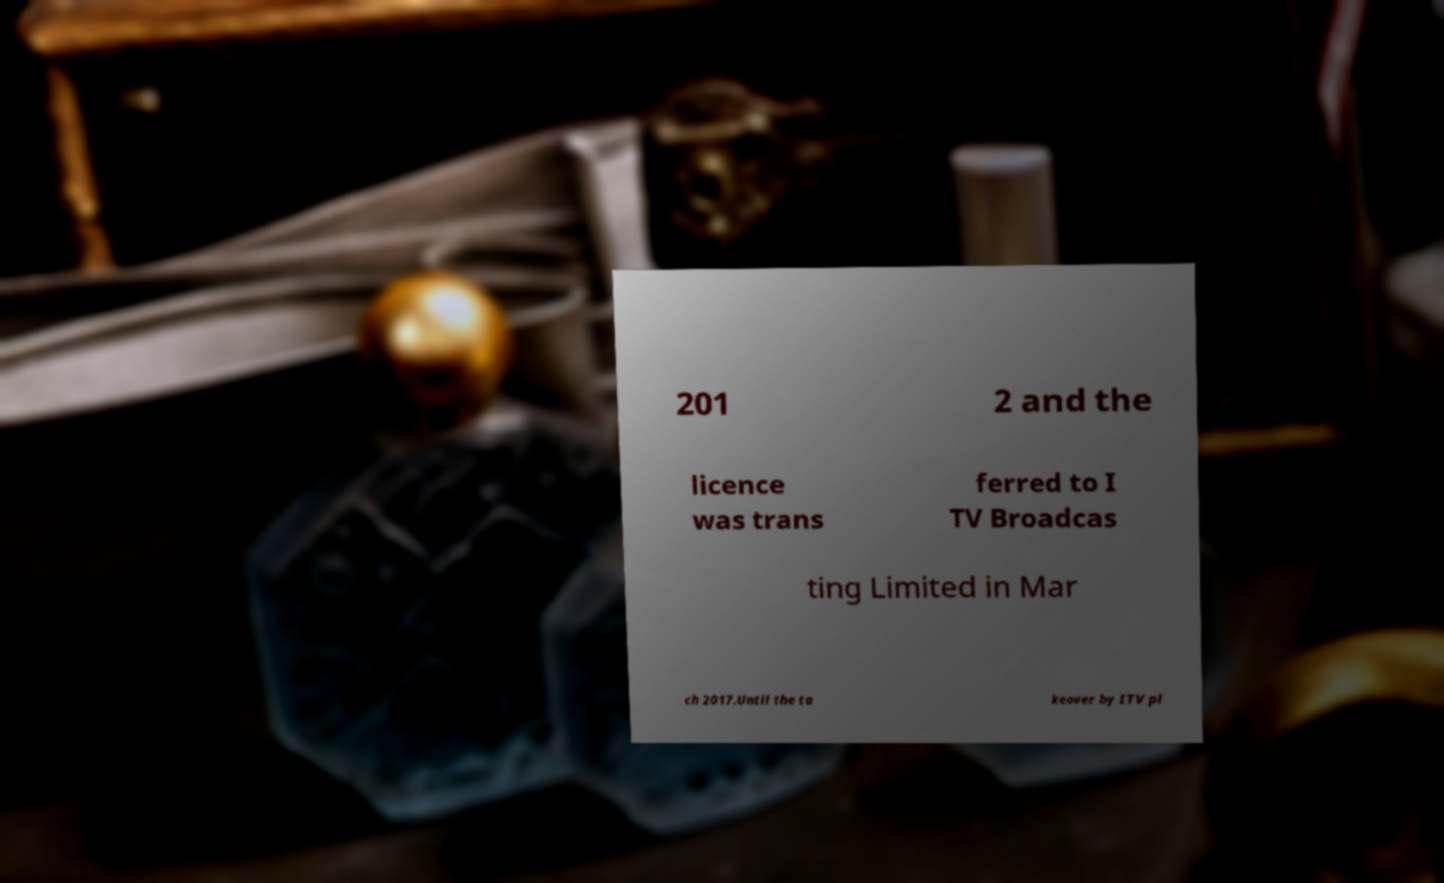There's text embedded in this image that I need extracted. Can you transcribe it verbatim? 201 2 and the licence was trans ferred to I TV Broadcas ting Limited in Mar ch 2017.Until the ta keover by ITV pl 